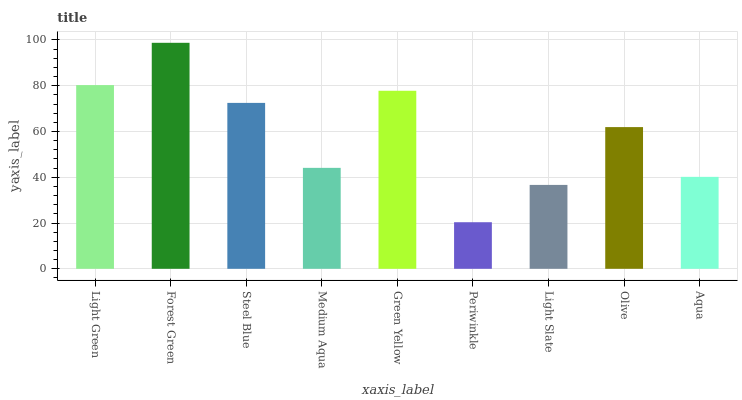Is Periwinkle the minimum?
Answer yes or no. Yes. Is Forest Green the maximum?
Answer yes or no. Yes. Is Steel Blue the minimum?
Answer yes or no. No. Is Steel Blue the maximum?
Answer yes or no. No. Is Forest Green greater than Steel Blue?
Answer yes or no. Yes. Is Steel Blue less than Forest Green?
Answer yes or no. Yes. Is Steel Blue greater than Forest Green?
Answer yes or no. No. Is Forest Green less than Steel Blue?
Answer yes or no. No. Is Olive the high median?
Answer yes or no. Yes. Is Olive the low median?
Answer yes or no. Yes. Is Aqua the high median?
Answer yes or no. No. Is Steel Blue the low median?
Answer yes or no. No. 